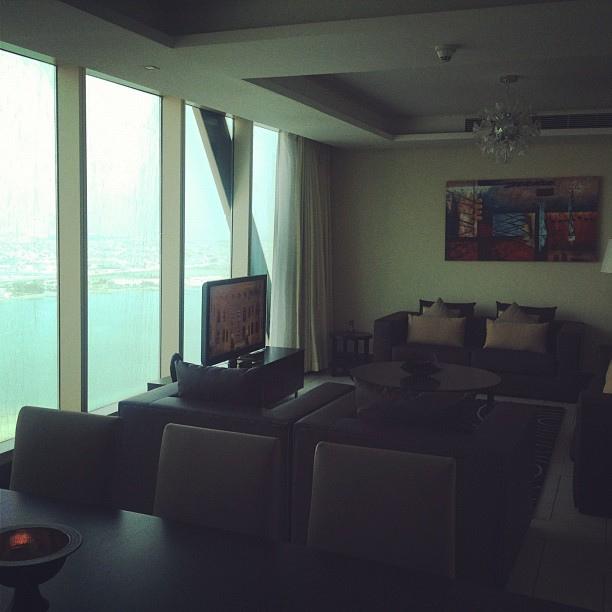Is this oceanfront?
Short answer required. Yes. Would most people describe this room as cozy?
Short answer required. Yes. What can been seen out the windows?
Quick response, please. Water. Is it raining?
Concise answer only. No. Is the light on?
Short answer required. No. 